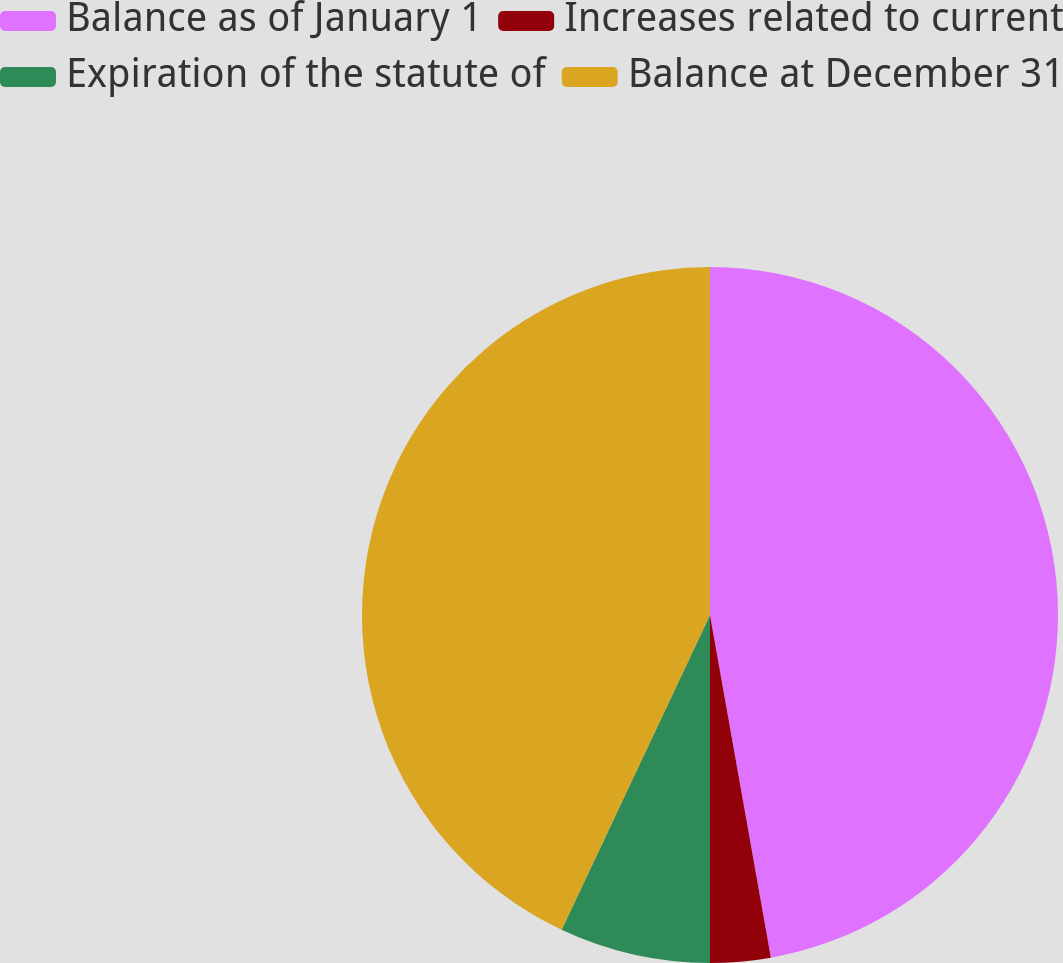Convert chart. <chart><loc_0><loc_0><loc_500><loc_500><pie_chart><fcel>Balance as of January 1<fcel>Increases related to current<fcel>Expiration of the statute of<fcel>Balance at December 31<nl><fcel>47.2%<fcel>2.8%<fcel>7.01%<fcel>42.99%<nl></chart> 